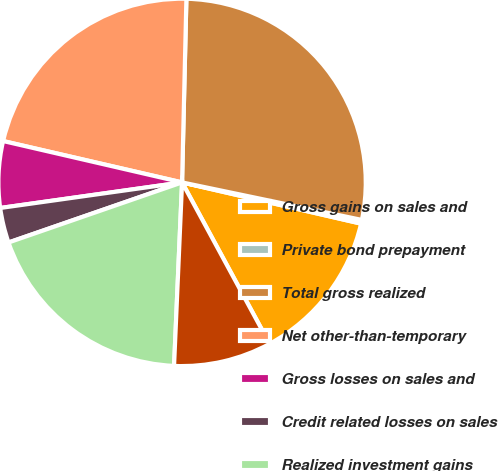Convert chart. <chart><loc_0><loc_0><loc_500><loc_500><pie_chart><fcel>Gross gains on sales and<fcel>Private bond prepayment<fcel>Total gross realized<fcel>Net other-than-temporary<fcel>Gross losses on sales and<fcel>Credit related losses on sales<fcel>Realized investment gains<fcel>Net gains (losses) on sales<nl><fcel>13.49%<fcel>0.33%<fcel>27.9%<fcel>21.76%<fcel>5.84%<fcel>3.08%<fcel>19.0%<fcel>8.6%<nl></chart> 